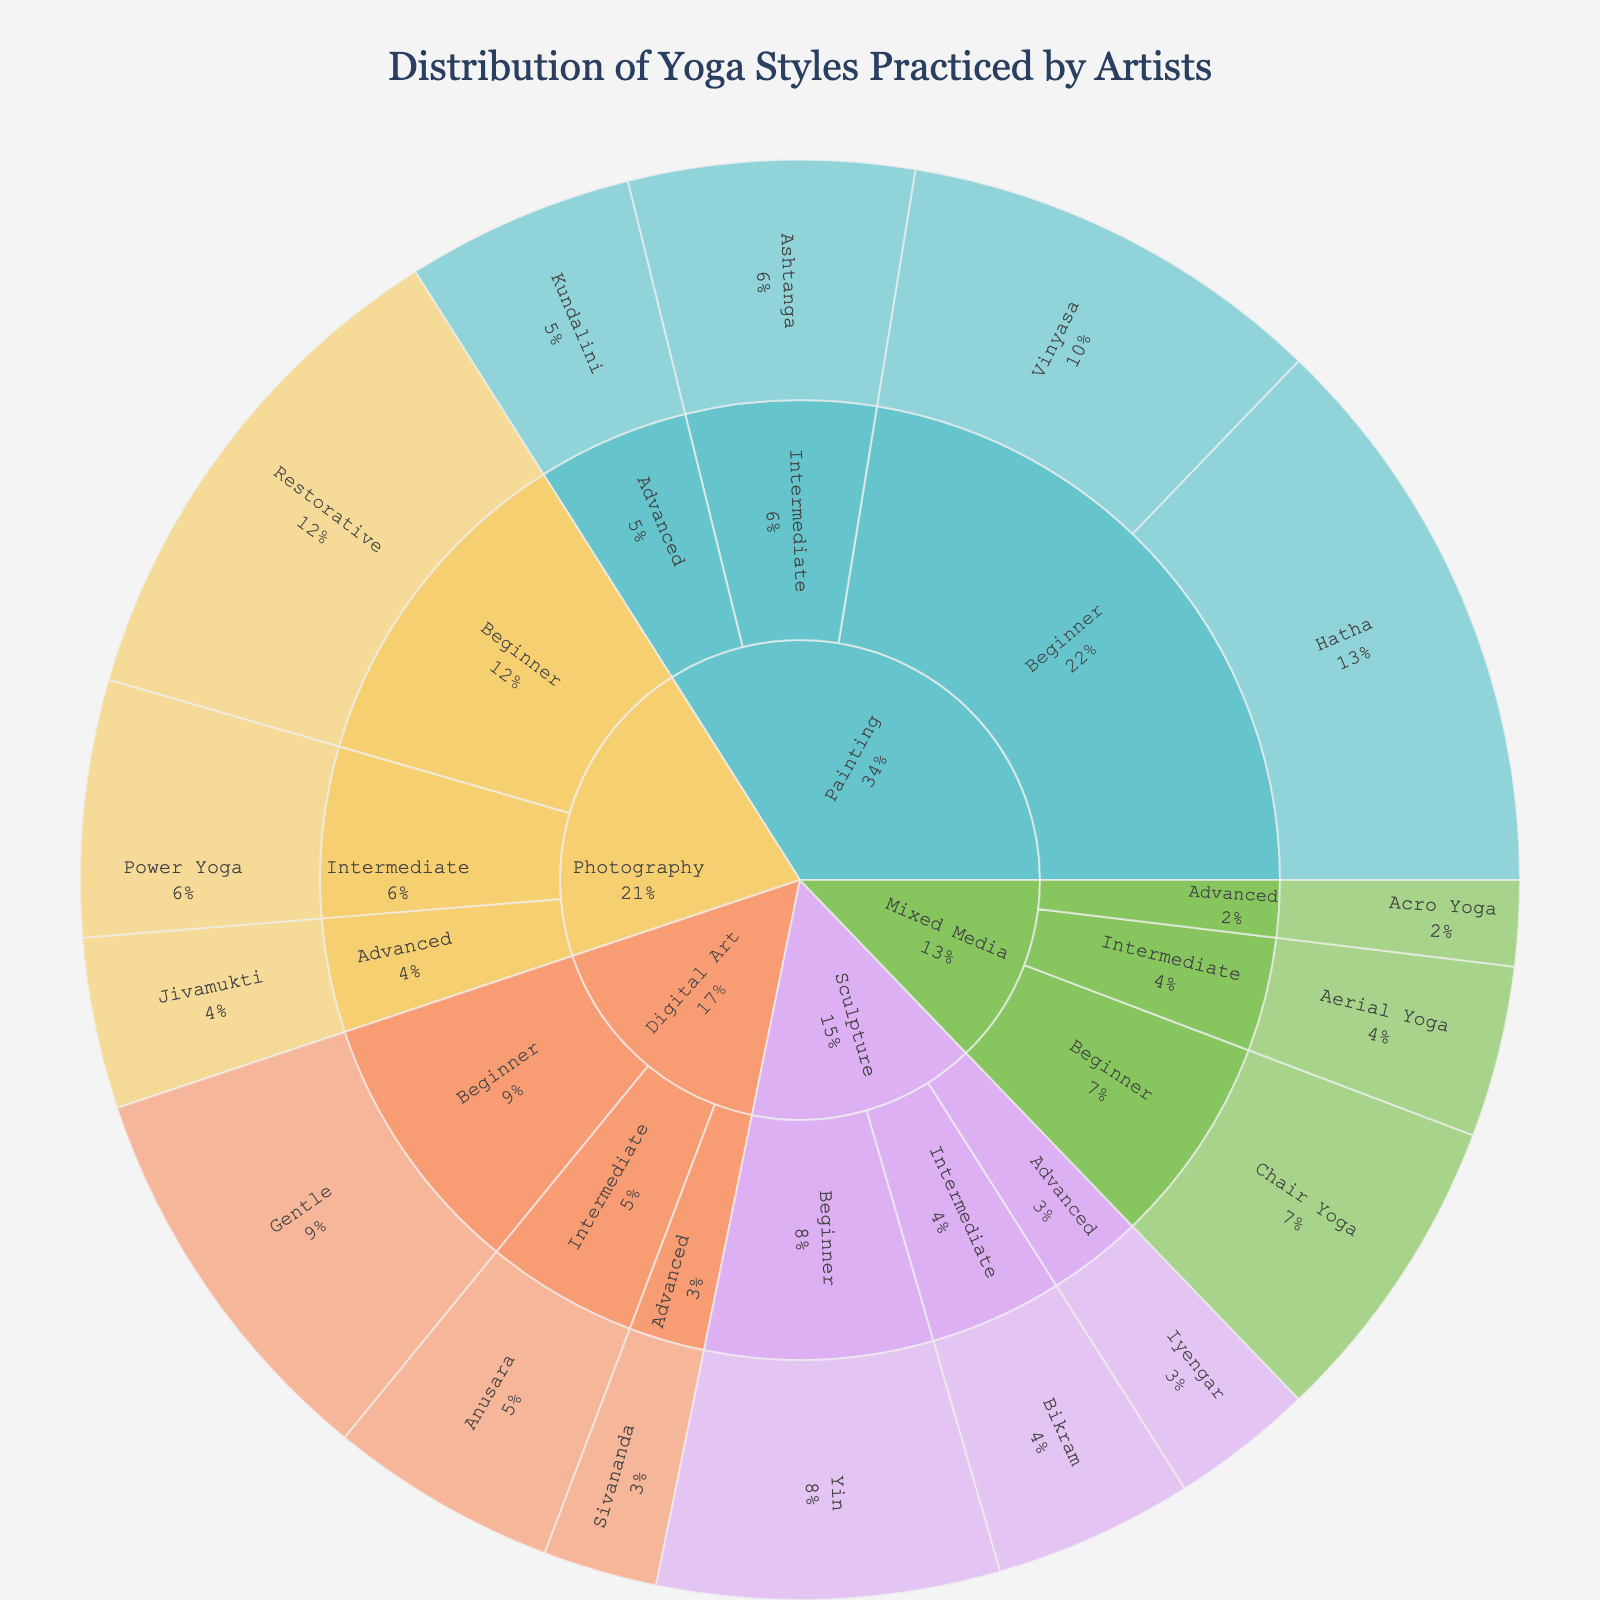What's the most common yoga style practiced by beginner painters? The sunburst plot shows that beginner painters have several segments each representing a different yoga style with differing percentages. The largest section represents Hatha yoga with a percentage of 20%.
Answer: Hatha Which art medium has the highest percentage of practitioners doing Restorative yoga? By looking at the segments colored differently for each art medium and labeled Restorative yoga, it's evident that only Photography has a segment for Restorative yoga with a percentage of 18%.
Answer: Photography What is the total percentage of yoga practitioners advanced in their respective art mediums? Add the percentages of advanced practitioners across all art mediums: Painting (8%) + Sculpture (5%) + Photography (6%) + Digital Art (4%) + Mixed Media (3%). This equals to 26%.
Answer: 26% Is Vinyasa yoga more popular among beginner or intermediate painters? For Vinyasa yoga, there is a segment labeled for beginner painters with a percentage of 15%. There is no segment for intermediate painters practicing Vinyasa yoga.
Answer: Beginner How does the percentage of beginner digital artists practicing Gentle yoga compare to beginner mixed media artists practicing Chair yoga? Examine the sunburst segments for Gentle yoga among beginner digital artists and Chair yoga among beginner mixed media artists. Gentle yoga for digital artists is 14%, while Chair yoga for mixed media is 11%. Gentle yoga is higher.
Answer: Gentle yoga is higher Which experience level among sculpture artists has the lowest percentage of practicing a particular yoga style, and what is that style? Reviewing the segments by experience level within Sculpture: Beginner with Yin yoga (12%), Intermediate with Bikram yoga (7%), and Advanced with Iyengar yoga (5%). The lowest is Advanced with Iyengar yoga at 5%.
Answer: Advanced, Iyengar What is the least practiced yoga style among advanced photographers? Identify the segment under Advanced level within Photography. Only one style, Jivamukti, is listed there with a percentage of 6%. Since there's only one style, it is also the least practiced.
Answer: Jivamukti Compare the percentage of intermediate artists practicing Power Yoga with intermediate artists practicing Aerial Yoga. Look at the corresponding segments under Intermediate level: Power Yoga by Photography (9%) and Aerial Yoga by Mixed Media (6%). Power Yoga has a higher percentage.
Answer: Power Yoga has a higher percentage 